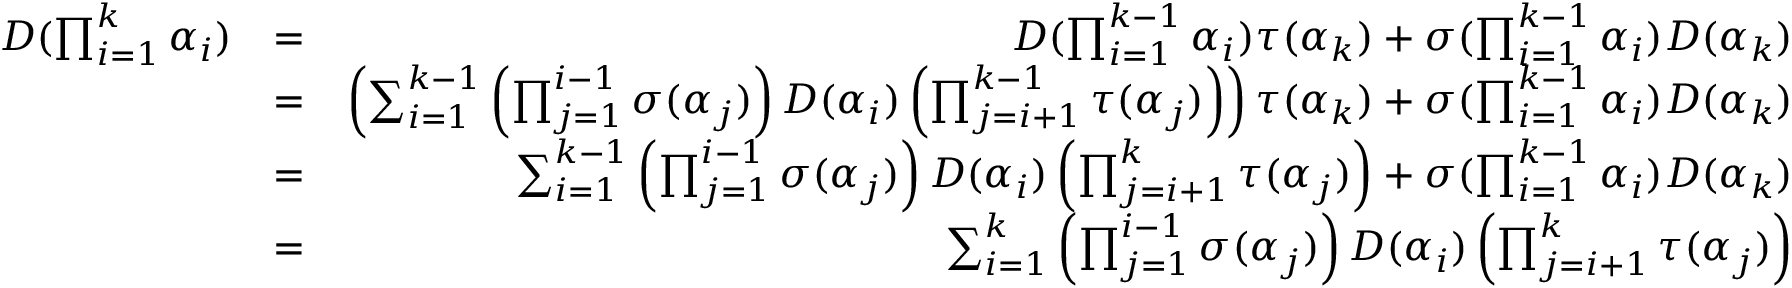Convert formula to latex. <formula><loc_0><loc_0><loc_500><loc_500>\begin{array} { r l r } { D ( \prod _ { i = 1 } ^ { k } \alpha _ { i } ) } & { = } & { D ( \prod _ { i = 1 } ^ { k - 1 } \alpha _ { i } ) \tau ( \alpha _ { k } ) + \sigma ( \prod _ { i = 1 } ^ { k - 1 } \alpha _ { i } ) D ( \alpha _ { k } ) } \\ & { = } & { \left ( \sum _ { i = 1 } ^ { k - 1 } \left ( \prod _ { j = 1 } ^ { i - 1 } \sigma ( \alpha _ { j } ) \right ) D ( \alpha _ { i } ) \left ( \prod _ { j = i + 1 } ^ { k - 1 } \tau ( \alpha _ { j } ) \right ) \right ) \tau ( \alpha _ { k } ) + \sigma ( \prod _ { i = 1 } ^ { k - 1 } \alpha _ { i } ) D ( \alpha _ { k } ) } \\ & { = } & { \sum _ { i = 1 } ^ { k - 1 } \left ( \prod _ { j = 1 } ^ { i - 1 } \sigma ( \alpha _ { j } ) \right ) D ( \alpha _ { i } ) \left ( \prod _ { j = i + 1 } ^ { k } \tau ( \alpha _ { j } ) \right ) + \sigma ( \prod _ { i = 1 } ^ { k - 1 } \alpha _ { i } ) D ( \alpha _ { k } ) } \\ & { = } & { \sum _ { i = 1 } ^ { k } \left ( \prod _ { j = 1 } ^ { i - 1 } \sigma ( \alpha _ { j } ) \right ) D ( \alpha _ { i } ) \left ( \prod _ { j = i + 1 } ^ { k } \tau ( \alpha _ { j } ) \right ) } \end{array}</formula> 